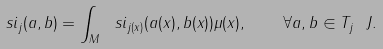<formula> <loc_0><loc_0><loc_500><loc_500>\ s i _ { j } ( a , b ) = \int _ { M } \ s i _ { j ( x ) } ( a ( x ) , b ( x ) ) \mu ( x ) , \quad \forall a , b \in T _ { j } \ J .</formula> 